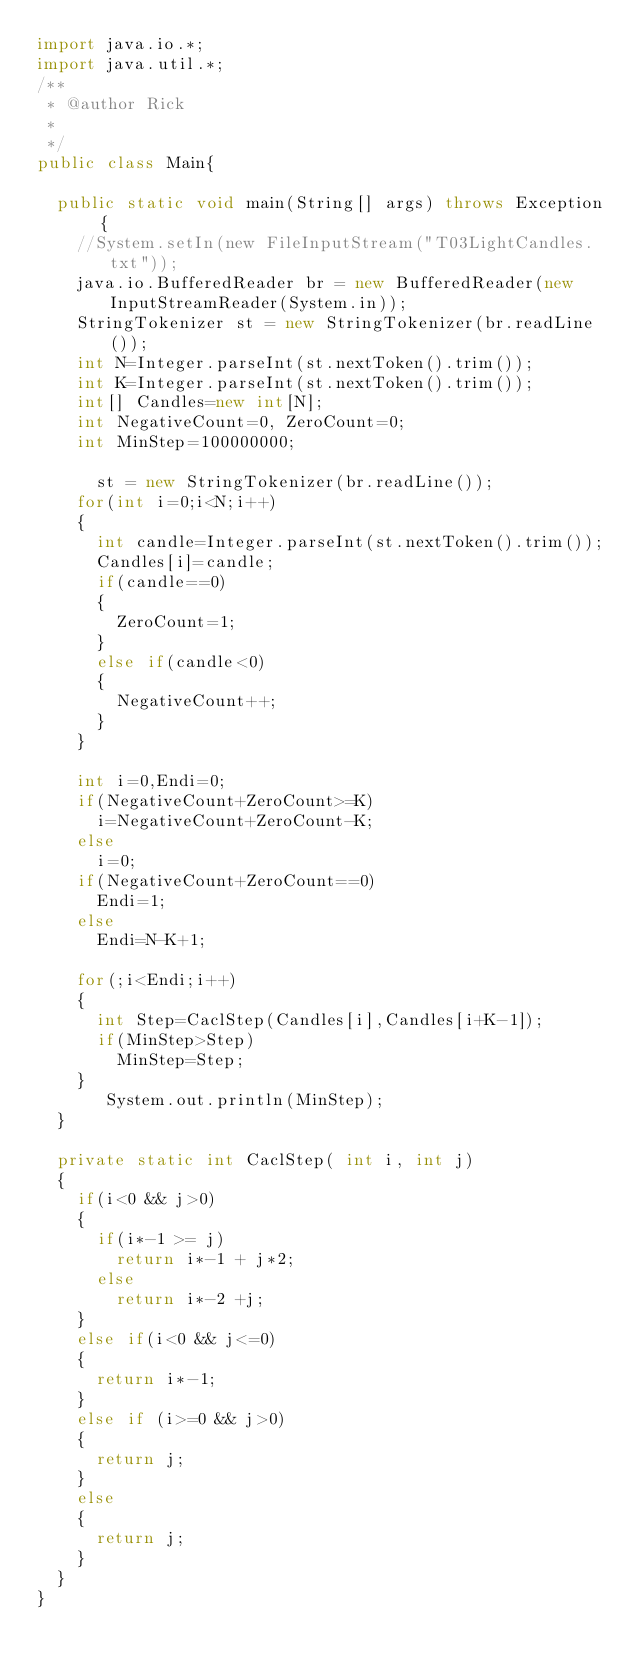<code> <loc_0><loc_0><loc_500><loc_500><_Java_>import java.io.*;
import java.util.*;
/**
 * @author Rick
 *
 */
public class Main{

	public static void main(String[] args) throws Exception {
		//System.setIn(new FileInputStream("T03LightCandles.txt"));
		java.io.BufferedReader br = new BufferedReader(new InputStreamReader(System.in));
		StringTokenizer st = new StringTokenizer(br.readLine());
		int N=Integer.parseInt(st.nextToken().trim());
		int K=Integer.parseInt(st.nextToken().trim());
		int[] Candles=new int[N];
		int NegativeCount=0, ZeroCount=0;
		int MinStep=100000000;
		
	    st = new StringTokenizer(br.readLine());
		for(int i=0;i<N;i++)
		{
			int candle=Integer.parseInt(st.nextToken().trim());
			Candles[i]=candle;
			if(candle==0)
			{
				ZeroCount=1;
			}
			else if(candle<0)
			{
				NegativeCount++;
			}
		}
		
		int i=0,Endi=0;
		if(NegativeCount+ZeroCount>=K)
			i=NegativeCount+ZeroCount-K;
		else
			i=0;
		if(NegativeCount+ZeroCount==0)
			Endi=1;
		else
			Endi=N-K+1;

		for(;i<Endi;i++)
		{
			int Step=CaclStep(Candles[i],Candles[i+K-1]);
			if(MinStep>Step)
				MinStep=Step;				
		}
	     System.out.println(MinStep);
	}
	
	private static int CaclStep( int i, int j)
	{
		if(i<0 && j>0)
		{
			if(i*-1 >= j)
				return i*-1 + j*2;
			else
				return i*-2 +j;
		}
		else if(i<0 && j<=0)
		{
			return i*-1;
		}
		else if (i>=0 && j>0)
		{ 
			return j;
		}
		else
		{ 
			return j;
		}
	}
}</code> 